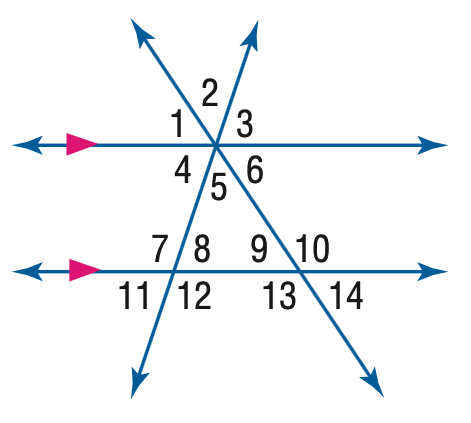Answer the mathemtical geometry problem and directly provide the correct option letter.
Question: In the figure, m \angle 11 = 62 and m \angle 14 = 38. Find the measure of \angle 2.
Choices: A: 38 B: 62 C: 80 D: 90 C 